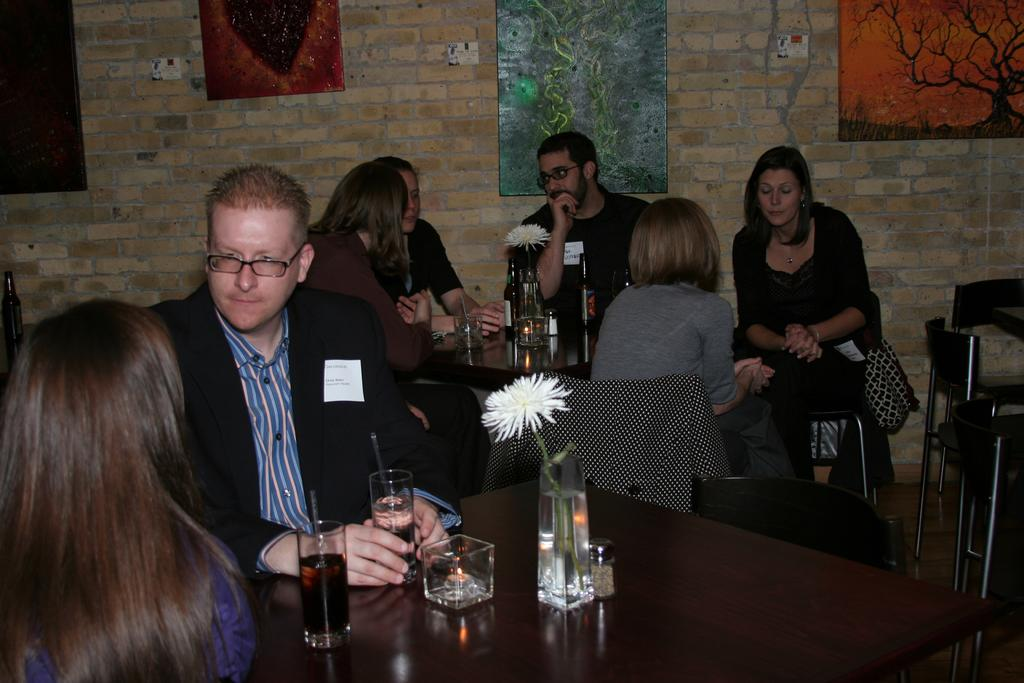What are the people in the image doing? The persons in the image are sitting on chairs around a table. What can be seen on the table? There are glasses, wine, a flower, and other objects on the table. What is the background of the image? There is a brick wall in the background with frames on it. What type of zinc is present on the table in the image? There is no zinc present on the table in the image. What color is the ink used to write on the lace in the image? There is no ink or lace present in the image. 